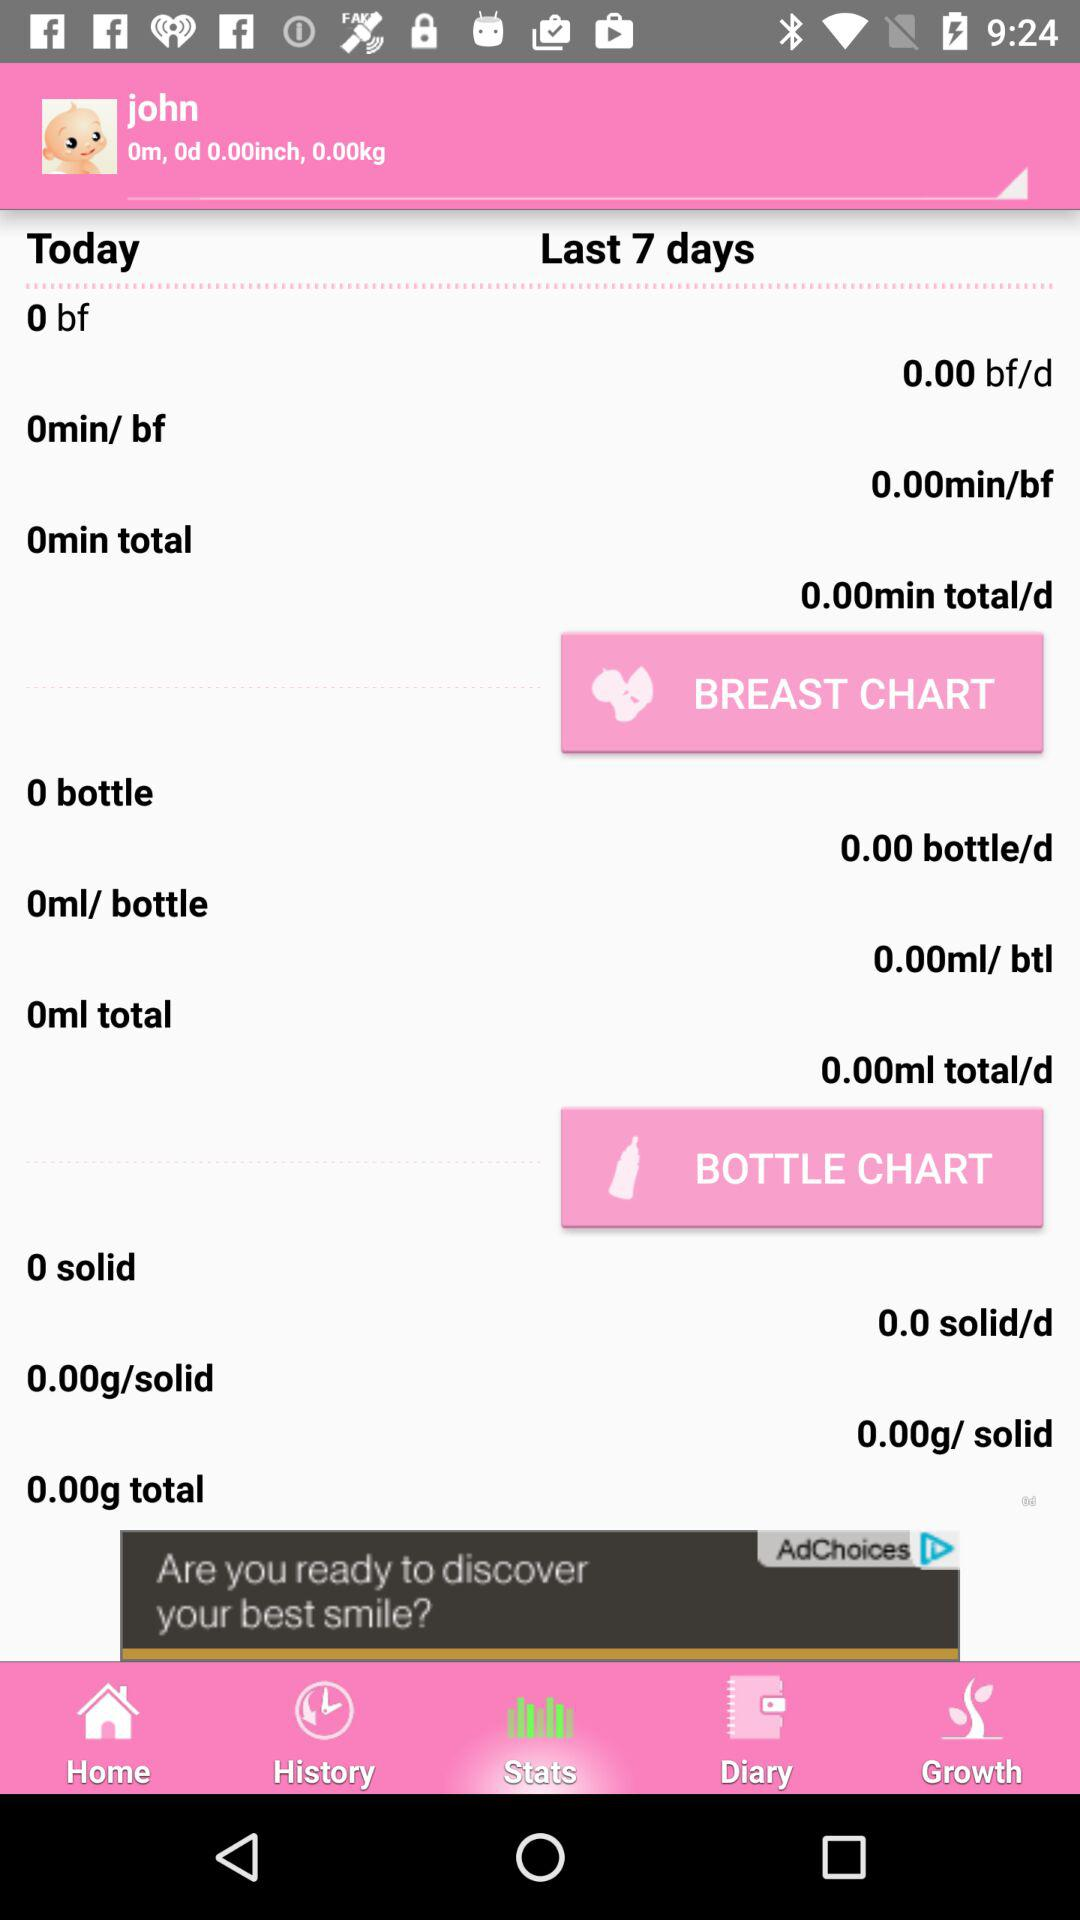For how many days is the data shown? The data is shown for the last 7 days. 